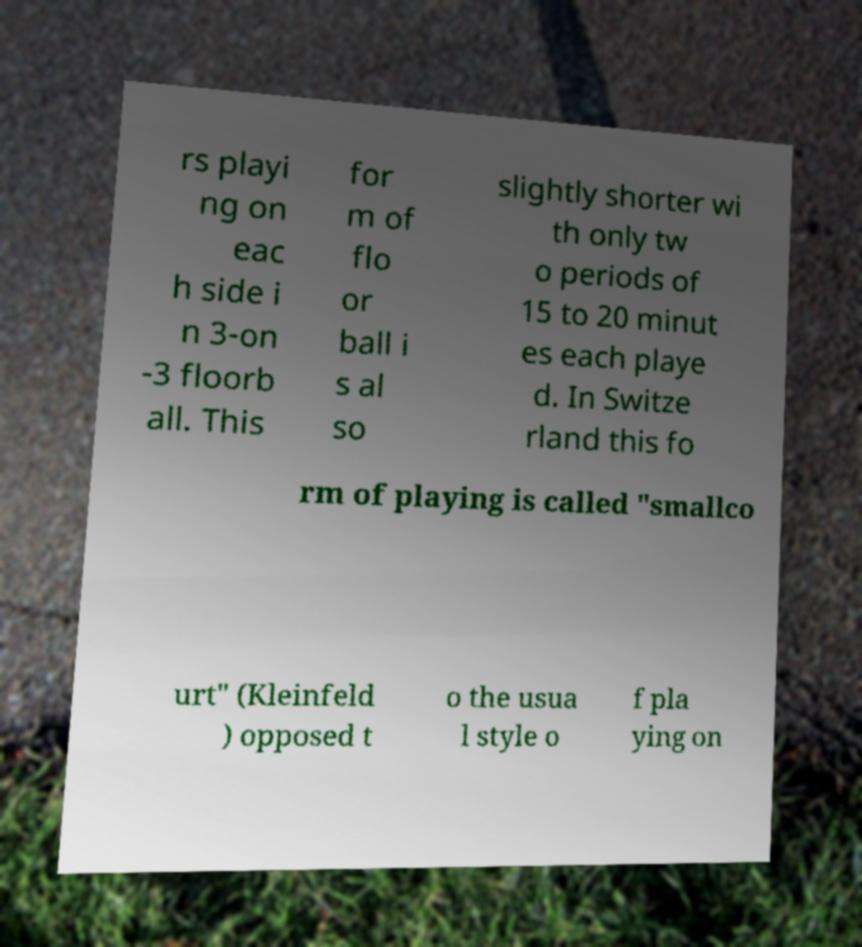There's text embedded in this image that I need extracted. Can you transcribe it verbatim? rs playi ng on eac h side i n 3-on -3 floorb all. This for m of flo or ball i s al so slightly shorter wi th only tw o periods of 15 to 20 minut es each playe d. In Switze rland this fo rm of playing is called "smallco urt" (Kleinfeld ) opposed t o the usua l style o f pla ying on 